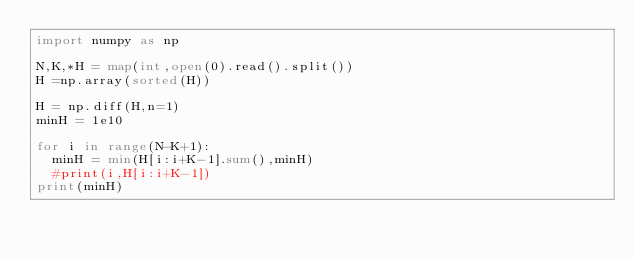<code> <loc_0><loc_0><loc_500><loc_500><_Python_>import numpy as np

N,K,*H = map(int,open(0).read().split())
H =np.array(sorted(H))

H = np.diff(H,n=1)
minH = 1e10

for i in range(N-K+1):
  minH = min(H[i:i+K-1].sum(),minH)
  #print(i,H[i:i+K-1])
print(minH)</code> 